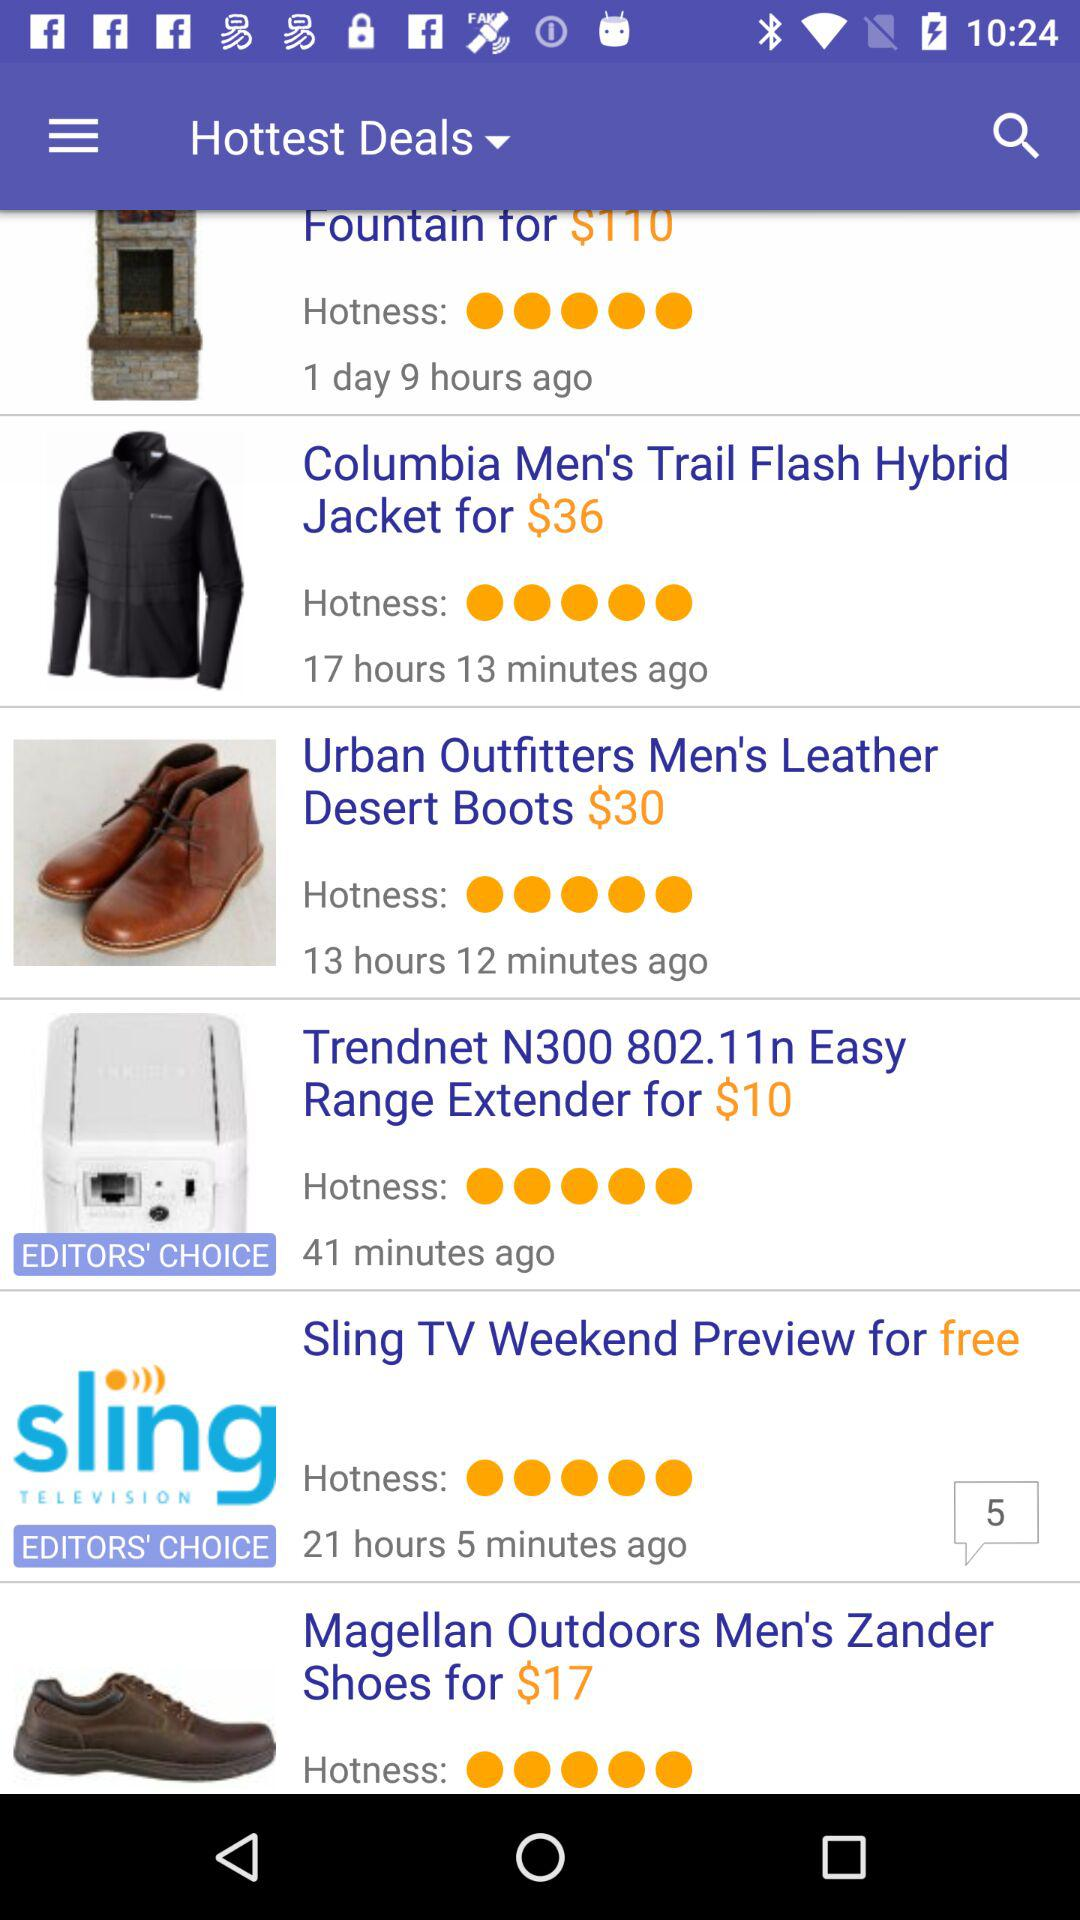When was the "Trendnet N300 802.11n Easy Range Extender" deal posted? The deal was posted 41 minutes ago. 